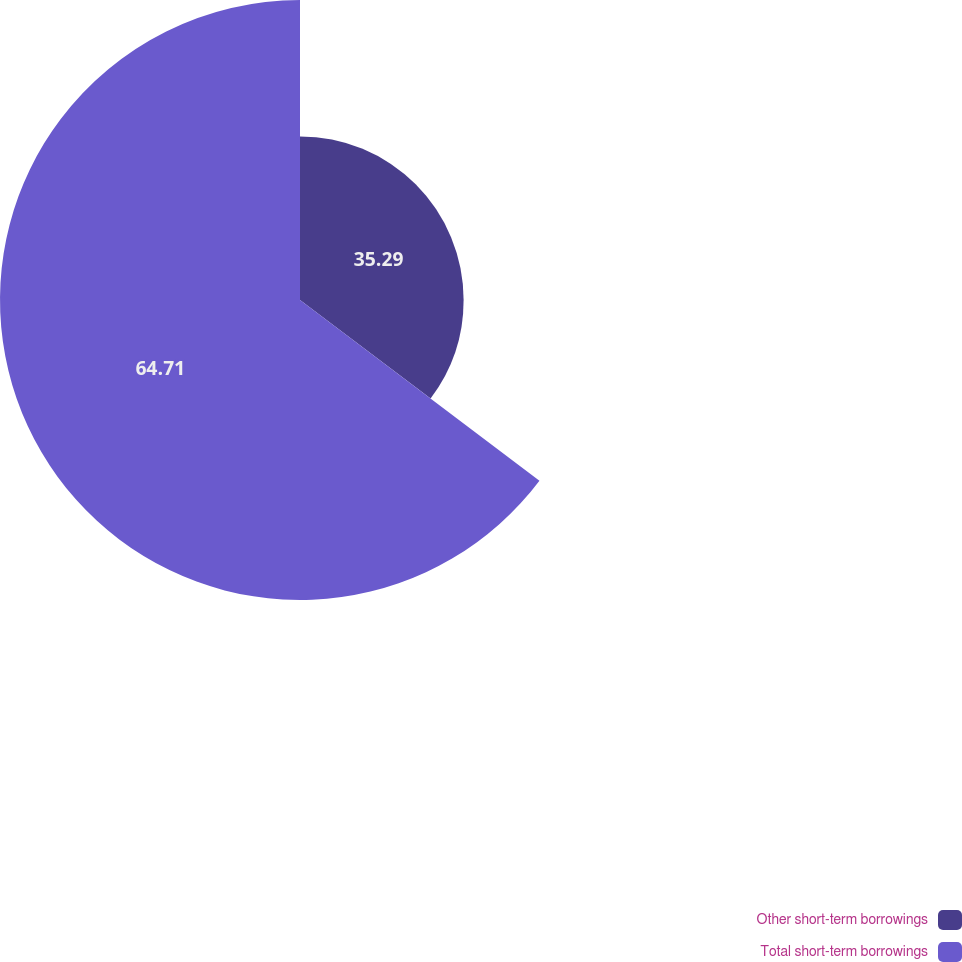Convert chart. <chart><loc_0><loc_0><loc_500><loc_500><pie_chart><fcel>Other short-term borrowings<fcel>Total short-term borrowings<nl><fcel>35.29%<fcel>64.71%<nl></chart> 